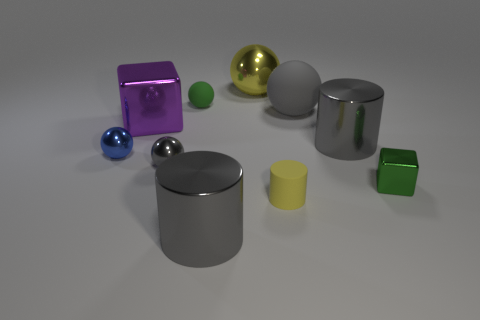Subtract all large cylinders. How many cylinders are left? 1 Subtract all gray cylinders. How many gray balls are left? 2 Subtract all green spheres. How many spheres are left? 4 Subtract 1 cylinders. How many cylinders are left? 2 Subtract all cylinders. How many objects are left? 7 Subtract all cyan cylinders. Subtract all cyan spheres. How many cylinders are left? 3 Subtract 0 red balls. How many objects are left? 10 Subtract all tiny matte things. Subtract all purple metallic objects. How many objects are left? 7 Add 7 purple metal blocks. How many purple metal blocks are left? 8 Add 7 green objects. How many green objects exist? 9 